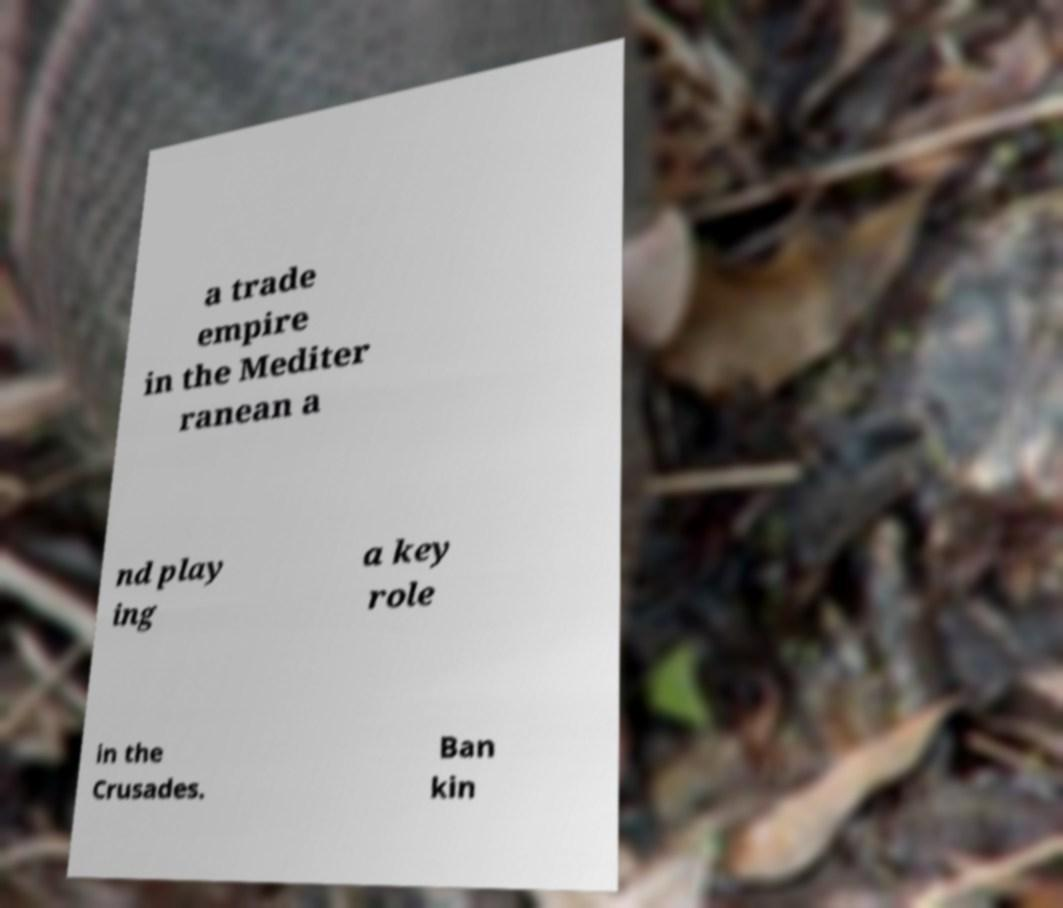Please read and relay the text visible in this image. What does it say? a trade empire in the Mediter ranean a nd play ing a key role in the Crusades. Ban kin 